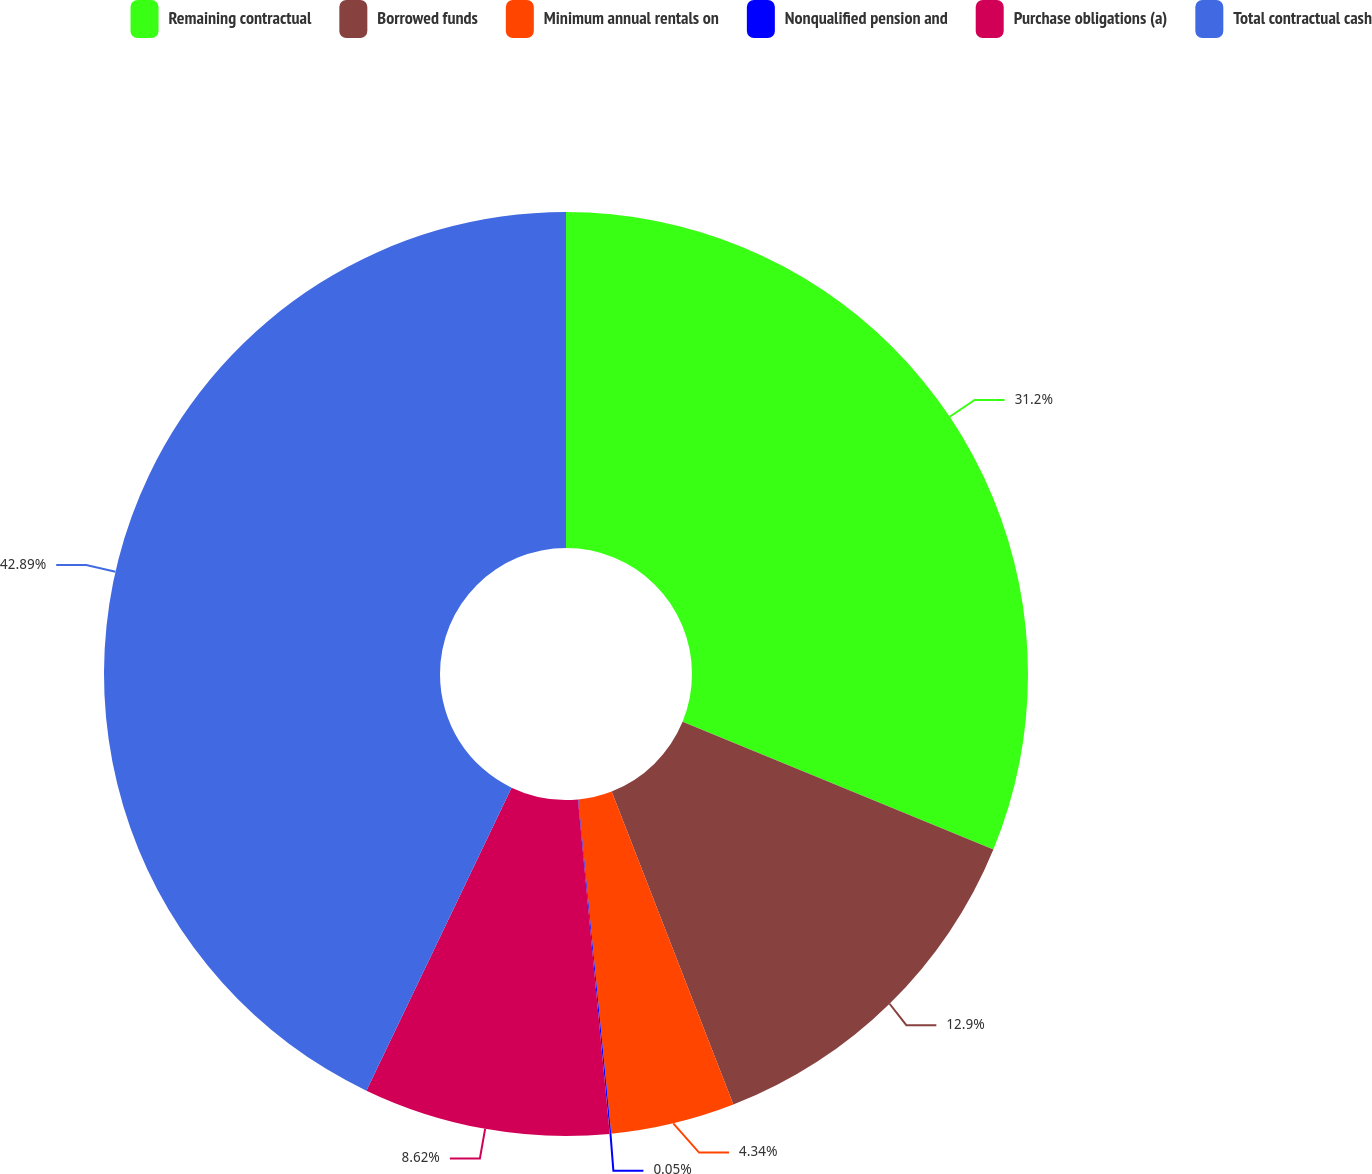Convert chart. <chart><loc_0><loc_0><loc_500><loc_500><pie_chart><fcel>Remaining contractual<fcel>Borrowed funds<fcel>Minimum annual rentals on<fcel>Nonqualified pension and<fcel>Purchase obligations (a)<fcel>Total contractual cash<nl><fcel>31.2%<fcel>12.9%<fcel>4.34%<fcel>0.05%<fcel>8.62%<fcel>42.89%<nl></chart> 